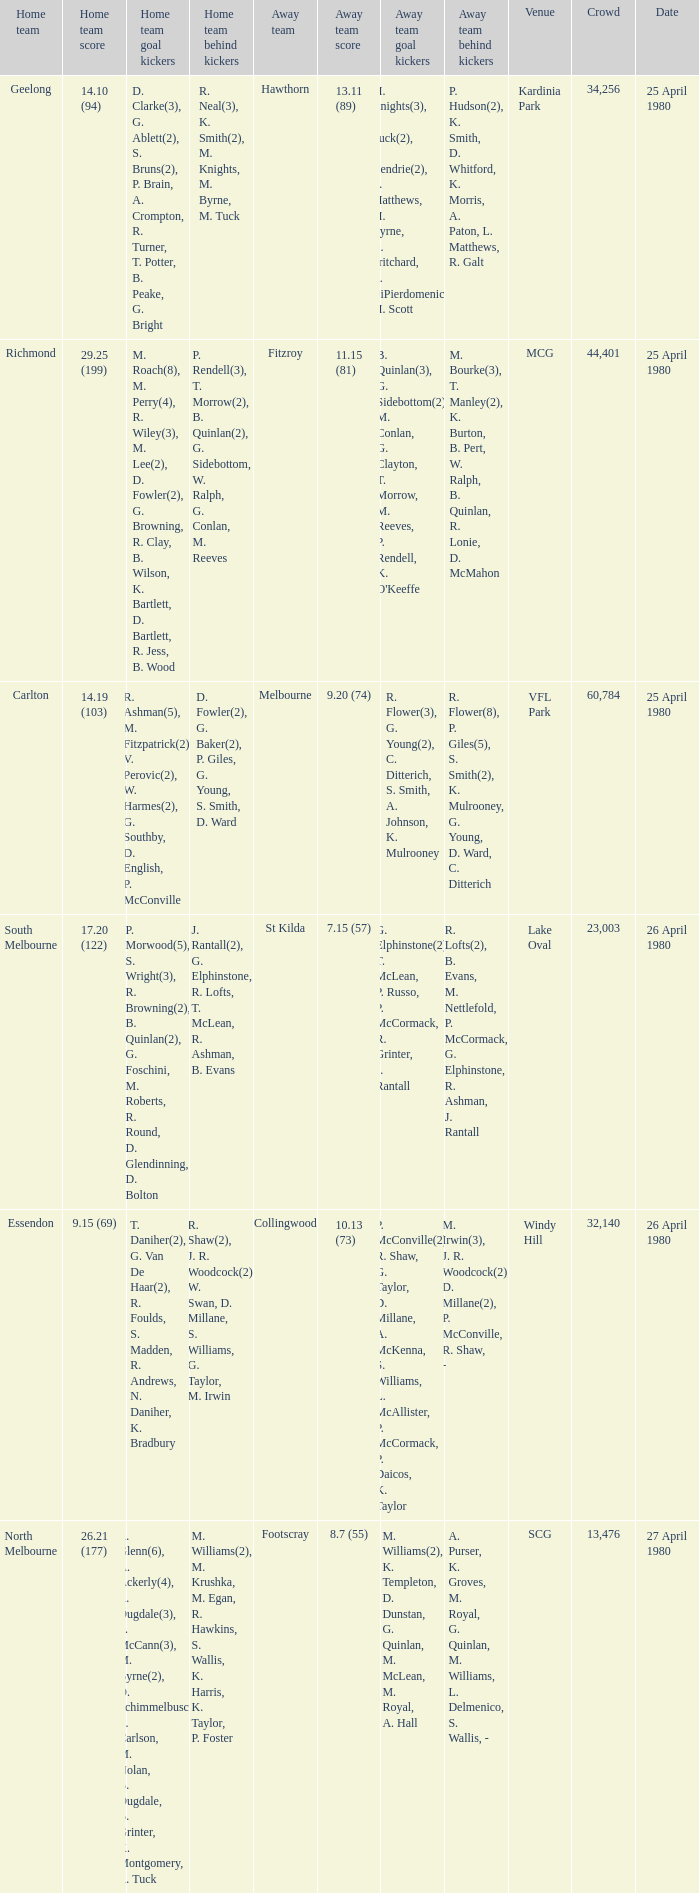Can you parse all the data within this table? {'header': ['Home team', 'Home team score', 'Home team goal kickers', 'Home team behind kickers', 'Away team', 'Away team score', 'Away team goal kickers', 'Away team behind kickers', 'Venue', 'Crowd', 'Date'], 'rows': [['Geelong', '14.10 (94)', 'D. Clarke(3), G. Ablett(2), S. Bruns(2), P. Brain, A. Crompton, R. Turner, T. Potter, B. Peake, G. Bright', 'R. Neal(3), K. Smith(2), M. Knights, M. Byrne, M. Tuck', 'Hawthorn', '13.11 (89)', 'M. Knights(3), P. Tuck(2), J. Hendrie(2), L. Matthews, M. Byrne, D. Pritchard, R. DiPierdomenico, M. Scott', 'P. Hudson(2), K. Smith, D. Whitford, K. Morris, A. Paton, L. Matthews, R. Galt', 'Kardinia Park', '34,256', '25 April 1980'], ['Richmond', '29.25 (199)', 'M. Roach(8), M. Perry(4), R. Wiley(3), M. Lee(2), D. Fowler(2), G. Browning, R. Clay, B. Wilson, K. Bartlett, D. Bartlett, R. Jess, B. Wood', 'P. Rendell(3), T. Morrow(2), B. Quinlan(2), G. Sidebottom, W. Ralph, G. Conlan, M. Reeves', 'Fitzroy', '11.15 (81)', "B. Quinlan(3), G. Sidebottom(2), M. Conlan, G. Clayton, T. Morrow, M. Reeves, P. Rendell, K. O'Keeffe", 'M. Bourke(3), T. Manley(2), K. Burton, B. Pert, W. Ralph, B. Quinlan, R. Lonie, D. McMahon', 'MCG', '44,401', '25 April 1980'], ['Carlton', '14.19 (103)', 'R. Ashman(5), M. Fitzpatrick(2), V. Perovic(2), W. Harmes(2), G. Southby, D. English, P. McConville', 'D. Fowler(2), G. Baker(2), P. Giles, G. Young, S. Smith, D. Ward', 'Melbourne', '9.20 (74)', 'R. Flower(3), G. Young(2), C. Ditterich, S. Smith, A. Johnson, K. Mulrooney', 'R. Flower(8), P. Giles(5), S. Smith(2), K. Mulrooney, G. Young, D. Ward, C. Ditterich', 'VFL Park', '60,784', '25 April 1980'], ['South Melbourne', '17.20 (122)', 'P. Morwood(5), S. Wright(3), R. Browning(2), B. Quinlan(2), G. Foschini, M. Roberts, R. Round, D. Glendinning, D. Bolton', 'J. Rantall(2), G. Elphinstone, R. Lofts, T. McLean, R. Ashman, B. Evans', 'St Kilda', '7.15 (57)', 'G. Elphinstone(2), T. McLean, P. Russo, P. McCormack, R. Grinter, J. Rantall', 'R. Lofts(2), B. Evans, M. Nettlefold, P. McCormack, G. Elphinstone, R. Ashman, J. Rantall', 'Lake Oval', '23,003', '26 April 1980'], ['Essendon', '9.15 (69)', 'T. Daniher(2), G. Van De Haar(2), R. Foulds, S. Madden, R. Andrews, N. Daniher, K. Bradbury', 'R. Shaw(2), J. R. Woodcock(2), W. Swan, D. Millane, S. Williams, G. Taylor, M. Irwin', 'Collingwood', '10.13 (73)', 'P. McConville(2), R. Shaw, G. Taylor, D. Millane, A. McKenna, S. Williams, L. McAllister, P. McCormack, P. Daicos, K. Taylor', 'M. Irwin(3), J. R. Woodcock(2), D. Millane(2), P. McConville, R. Shaw, -', 'Windy Hill', '32,140', '26 April 1980'], ['North Melbourne', '26.21 (177)', 'R. Glenn(6), A. Ackerly(4), R. Dugdale(3), S. McCann(3), M. Byrne(2), D. Schimmelbusch, L. Carlson, M. Nolan, B. Dugdale, B. Grinter, K. Montgomery, R. Tuck', 'M. Williams(2), M. Krushka, M. Egan, R. Hawkins, S. Wallis, K. Harris, K. Taylor, P. Foster', 'Footscray', '8.7 (55)', 'M. Williams(2), K. Templeton, D. Dunstan, G. Quinlan, M. McLean, M. Royal, A. Hall', 'A. Purser, K. Groves, M. Royal, G. Quinlan, M. Williams, L. Delmenico, S. Wallis, -', 'SCG', '13,476', '27 April 1980']]} What wa the date of the North Melbourne home game? 27 April 1980. 